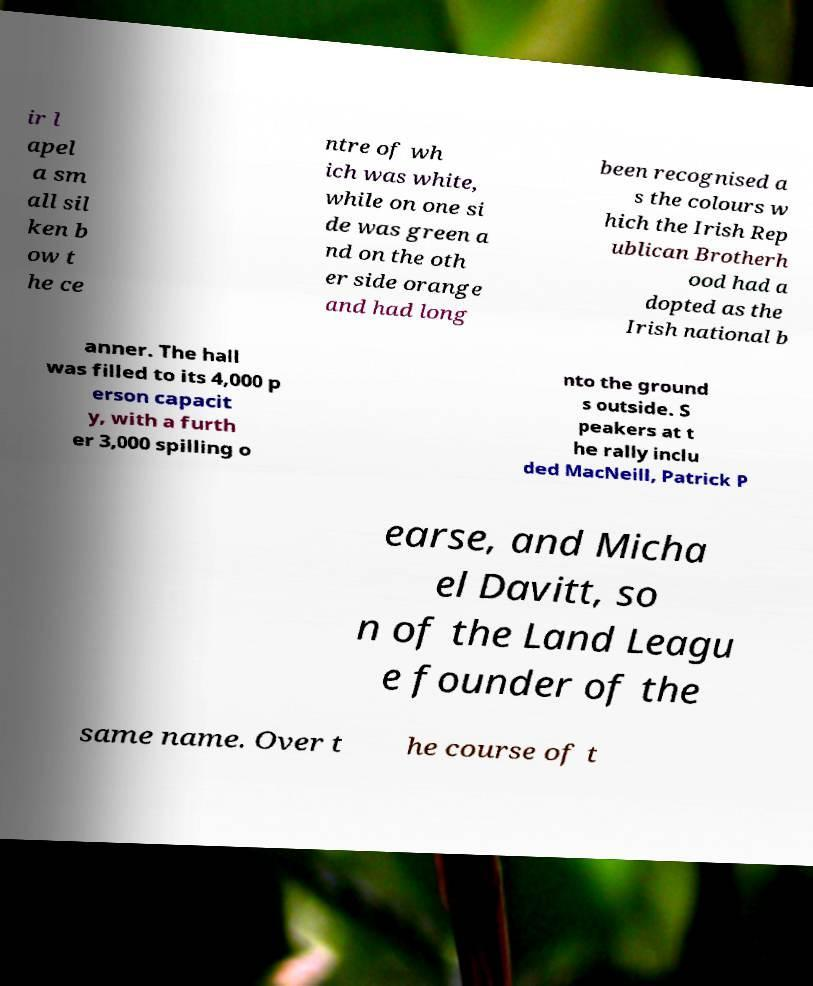Please read and relay the text visible in this image. What does it say? ir l apel a sm all sil ken b ow t he ce ntre of wh ich was white, while on one si de was green a nd on the oth er side orange and had long been recognised a s the colours w hich the Irish Rep ublican Brotherh ood had a dopted as the Irish national b anner. The hall was filled to its 4,000 p erson capacit y, with a furth er 3,000 spilling o nto the ground s outside. S peakers at t he rally inclu ded MacNeill, Patrick P earse, and Micha el Davitt, so n of the Land Leagu e founder of the same name. Over t he course of t 